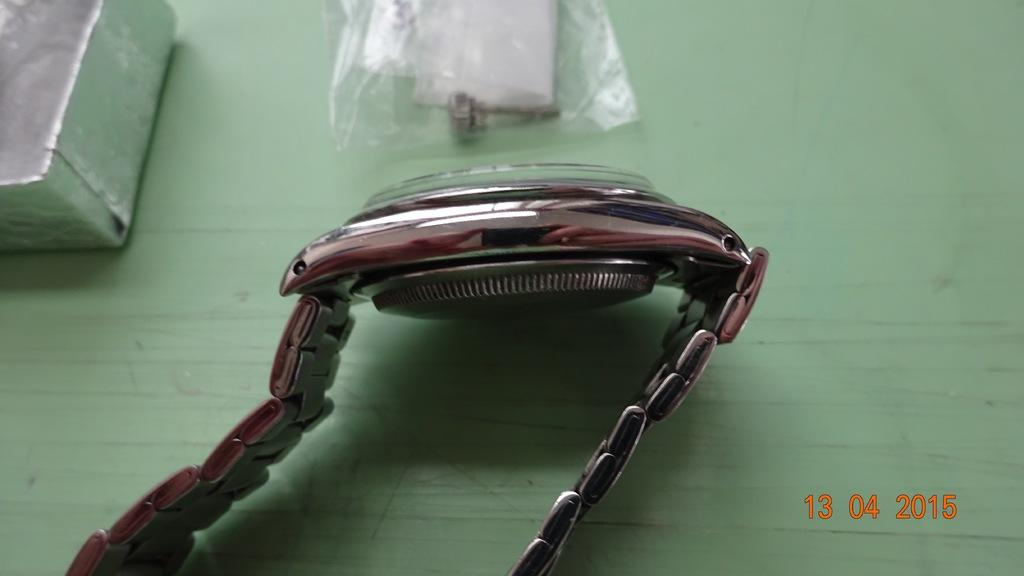What type of accessory is visible in the image? There is a wrist watch in the image. What is the color of the silver object in the image? The silver color object in the image is the wrist watch. What type of poison is present in the image? There is no poison present in the image; it only features a wrist watch. What book can be seen on the wrist watch in the image? There is no book present in the image, as it only features a wrist watch. 